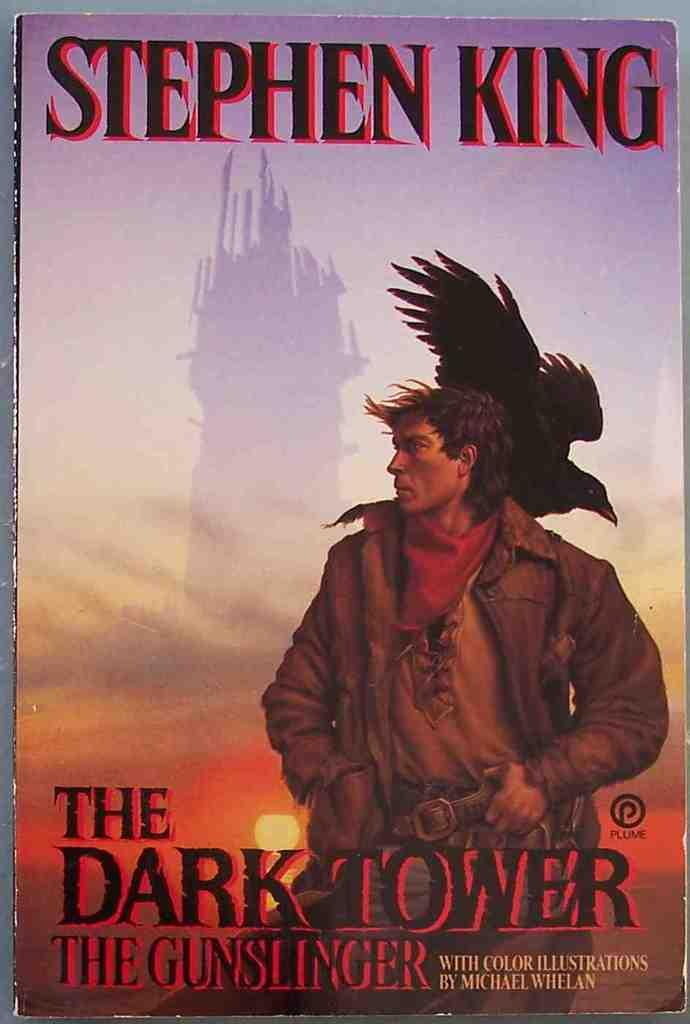Provide a one-sentence caption for the provided image. A Stephen King book called The Dark Tower The Gunslinger. 